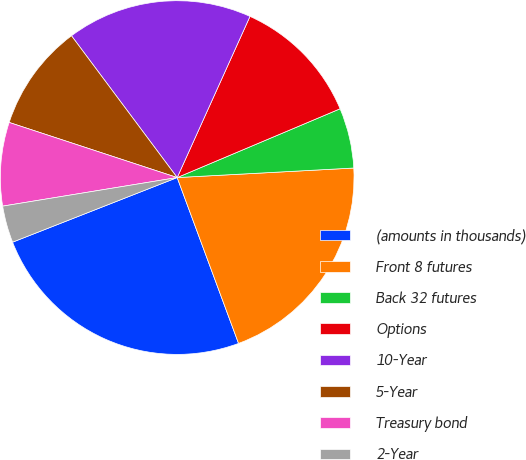Convert chart to OTSL. <chart><loc_0><loc_0><loc_500><loc_500><pie_chart><fcel>(amounts in thousands)<fcel>Front 8 futures<fcel>Back 32 futures<fcel>Options<fcel>10-Year<fcel>5-Year<fcel>Treasury bond<fcel>2-Year<nl><fcel>24.69%<fcel>20.22%<fcel>5.5%<fcel>11.89%<fcel>16.95%<fcel>9.76%<fcel>7.63%<fcel>3.37%<nl></chart> 